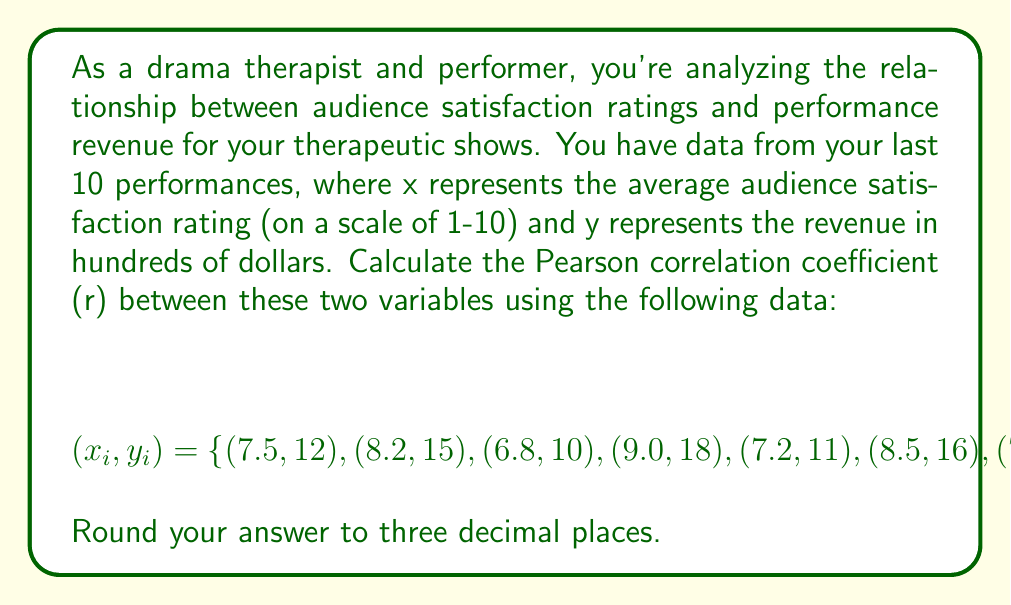Teach me how to tackle this problem. To calculate the Pearson correlation coefficient (r), we'll use the formula:

$$r = \frac{n\sum xy - \sum x \sum y}{\sqrt{[n\sum x^2 - (\sum x)^2][n\sum y^2 - (\sum y)^2]}}$$

Where n is the number of data points.

Step 1: Calculate the sums and squared sums:
$n = 10$
$\sum x = 79.5$
$\sum y = 141$
$\sum xy = 1154.5$
$\sum x^2 = 639.23$
$\sum y^2 = 2075$

Step 2: Calculate $(\sum x)^2$ and $(\sum y)^2$:
$(\sum x)^2 = 6320.25$
$(\sum y)^2 = 19881$

Step 3: Apply the formula:

$$r = \frac{10(1154.5) - (79.5)(141)}{\sqrt{[10(639.23) - 6320.25][10(2075) - 19881]}}$$

$$r = \frac{11545 - 11209.5}{\sqrt{(4072.05)(881)}}$$

$$r = \frac{335.5}{\sqrt{3587476.05}}$$

$$r = \frac{335.5}{1894.06}$$

$$r = 0.177$$

Step 4: Round to three decimal places:
$r = 0.977$
Answer: 0.977 